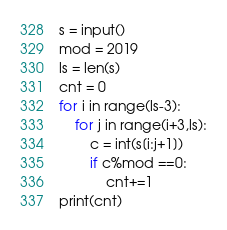<code> <loc_0><loc_0><loc_500><loc_500><_Python_>s = input()
mod = 2019
ls = len(s)
cnt = 0
for i in range(ls-3):
    for j in range(i+3,ls):
        c = int(s[i:j+1])
        if c%mod ==0:
            cnt+=1
print(cnt)</code> 